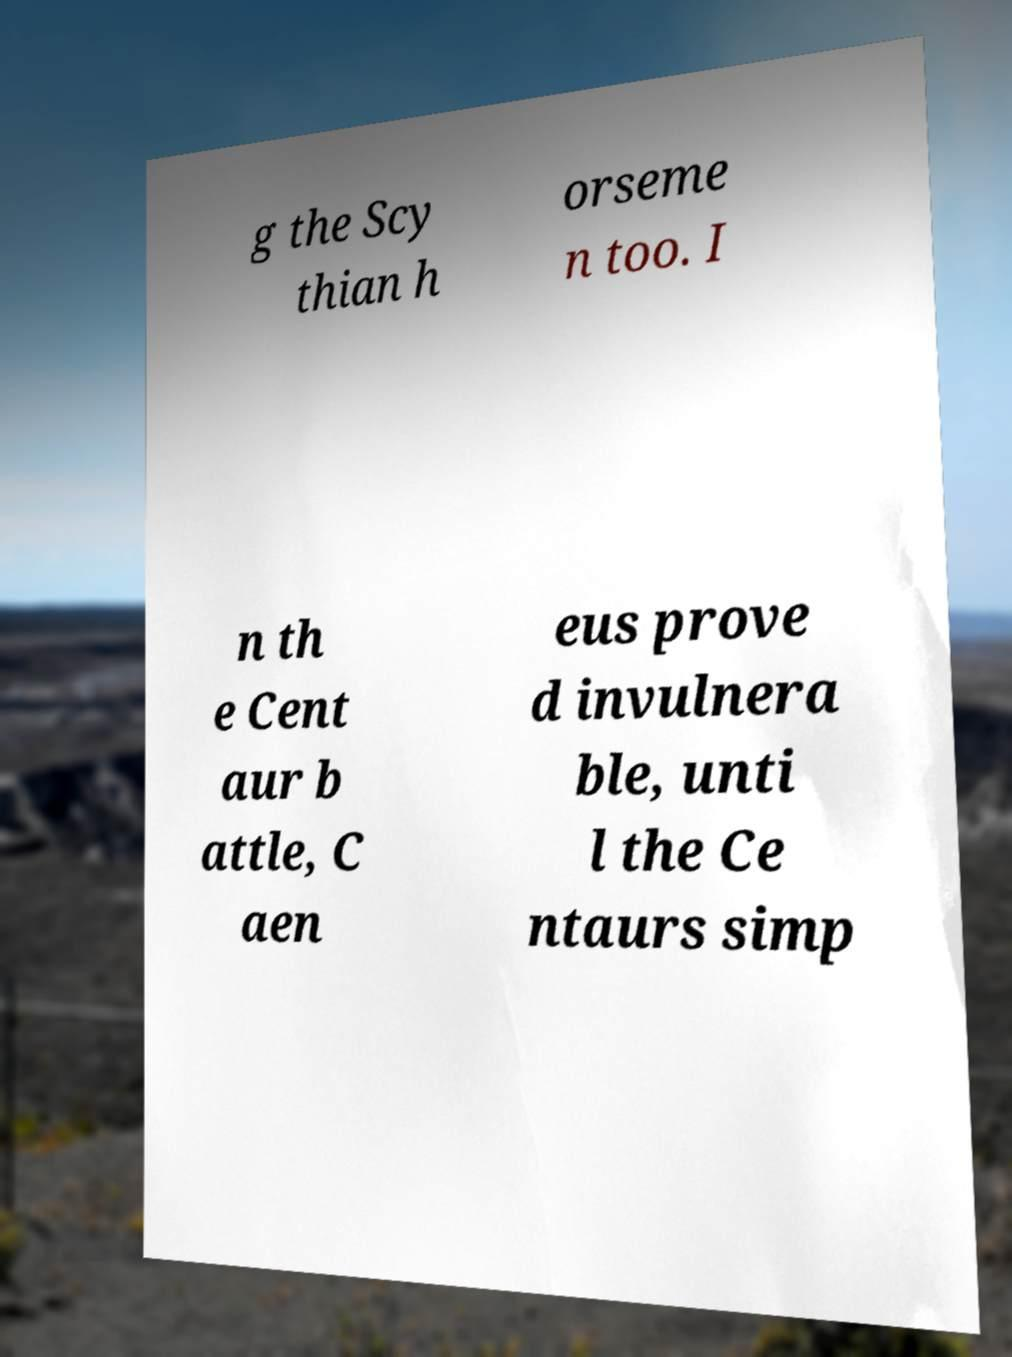Could you assist in decoding the text presented in this image and type it out clearly? g the Scy thian h orseme n too. I n th e Cent aur b attle, C aen eus prove d invulnera ble, unti l the Ce ntaurs simp 